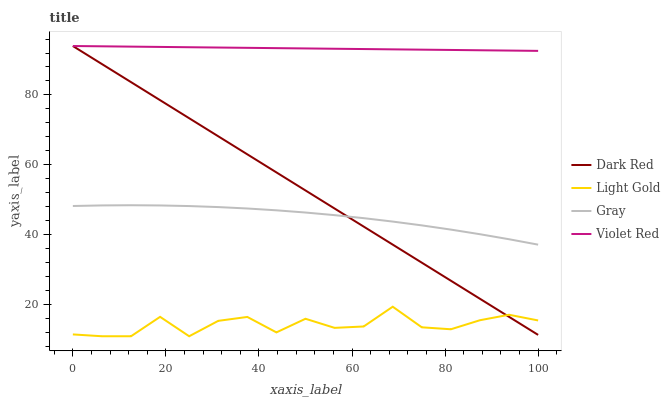Does Light Gold have the minimum area under the curve?
Answer yes or no. Yes. Does Violet Red have the maximum area under the curve?
Answer yes or no. Yes. Does Violet Red have the minimum area under the curve?
Answer yes or no. No. Does Light Gold have the maximum area under the curve?
Answer yes or no. No. Is Violet Red the smoothest?
Answer yes or no. Yes. Is Light Gold the roughest?
Answer yes or no. Yes. Is Light Gold the smoothest?
Answer yes or no. No. Is Violet Red the roughest?
Answer yes or no. No. Does Light Gold have the lowest value?
Answer yes or no. Yes. Does Violet Red have the lowest value?
Answer yes or no. No. Does Violet Red have the highest value?
Answer yes or no. Yes. Does Light Gold have the highest value?
Answer yes or no. No. Is Light Gold less than Violet Red?
Answer yes or no. Yes. Is Violet Red greater than Light Gold?
Answer yes or no. Yes. Does Dark Red intersect Violet Red?
Answer yes or no. Yes. Is Dark Red less than Violet Red?
Answer yes or no. No. Is Dark Red greater than Violet Red?
Answer yes or no. No. Does Light Gold intersect Violet Red?
Answer yes or no. No. 